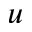Convert formula to latex. <formula><loc_0><loc_0><loc_500><loc_500>u</formula> 